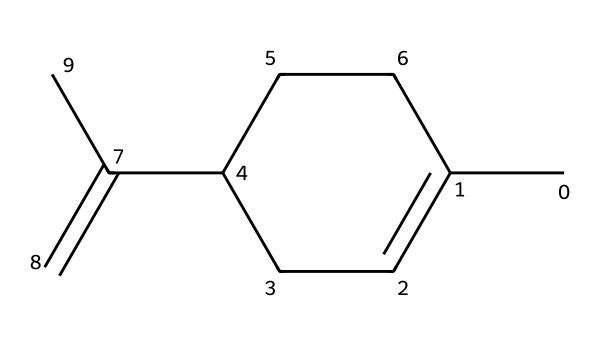What is the name of this chemical? The SMILES representation corresponds to a compound known as limonene, which is a cyclic monoterpene commonly found in citrus oils.
Answer: limonene How many carbon atoms are in limonene? In the provided SMILES, there are 10 carbon atoms indicated by the notation and structure. Each "C" represents a carbon atom.
Answer: 10 Is limonene a saturated or unsaturated compound? The presence of double bonds (as indicated by the "=" in the SMILES) shows that limonene has unsaturation, meaning it contains one or more double bonds.
Answer: unsaturated What functional group is predominant in limonene? The molecule features a hydrocarbon structure without any functional groups like -OH or -COOH, indicating it is an alkene due to the presence of carbon-carbon double bonds.
Answer: alkene What type of solvent is limonene? Limonene is considered a polar aprotic solvent due to its ability to dissolve certain compounds while lacking hydrogen bonds that would classify it as protic.
Answer: polar aprotic What is the molecular formula of limonene? By analyzing the SMILES representation, one can deduce that the molecular formula of limonene is C10H16 based on the count of carbon and hydrogen atoms.
Answer: C10H16 How many double bonds are there in limonene? In the structure of limonene represented by the SMILES, there are two double bonds indicated by the "=" signs that connect carbon atoms within the molecule.
Answer: 2 